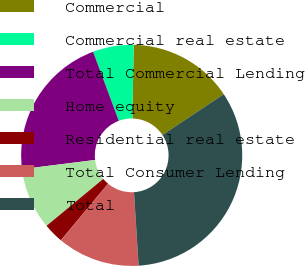<chart> <loc_0><loc_0><loc_500><loc_500><pie_chart><fcel>Commercial<fcel>Commercial real estate<fcel>Total Commercial Lending<fcel>Home equity<fcel>Residential real estate<fcel>Total Consumer Lending<fcel>Total<nl><fcel>15.37%<fcel>5.97%<fcel>21.31%<fcel>9.02%<fcel>2.93%<fcel>12.06%<fcel>33.34%<nl></chart> 